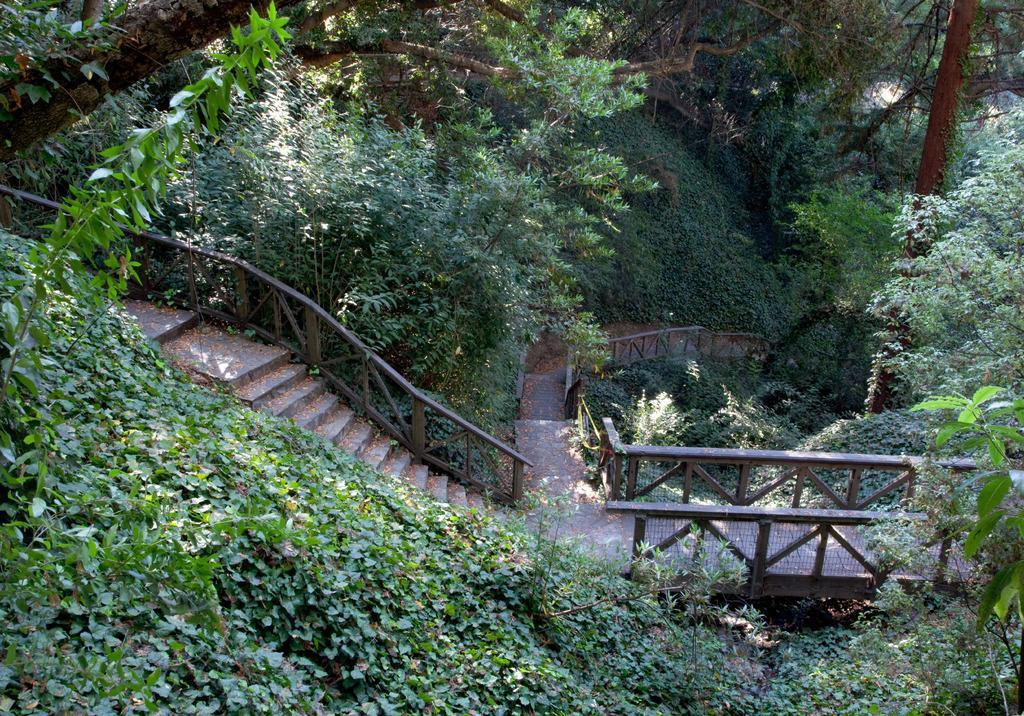Could you give a brief overview of what you see in this image? In the image we can see stairs, fence, grass and trees. 